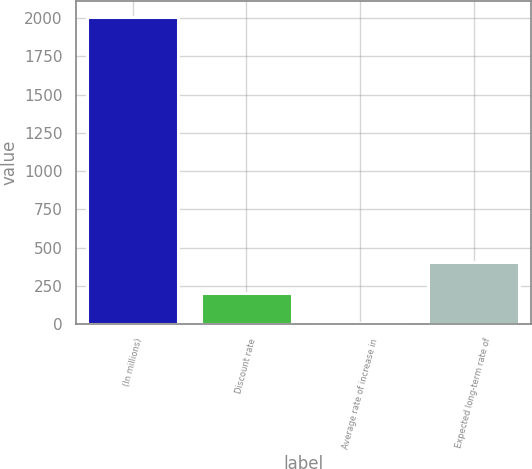Convert chart to OTSL. <chart><loc_0><loc_0><loc_500><loc_500><bar_chart><fcel>(In millions)<fcel>Discount rate<fcel>Average rate of increase in<fcel>Expected long-term rate of<nl><fcel>2011<fcel>204.7<fcel>4<fcel>405.4<nl></chart> 